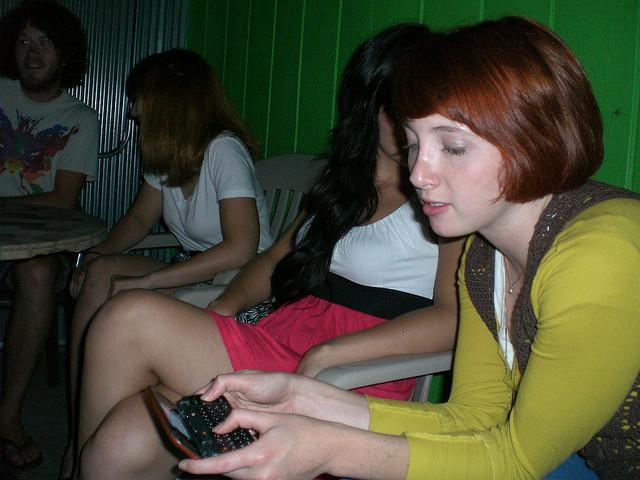How many people are in the photo?
Give a very brief answer. 4. How many people are in this photo?
Give a very brief answer. 4. How many arms are in view?
Give a very brief answer. 7. How many people are there?
Give a very brief answer. 4. How many chairs can you see?
Give a very brief answer. 2. How many cell phones can you see?
Give a very brief answer. 1. 